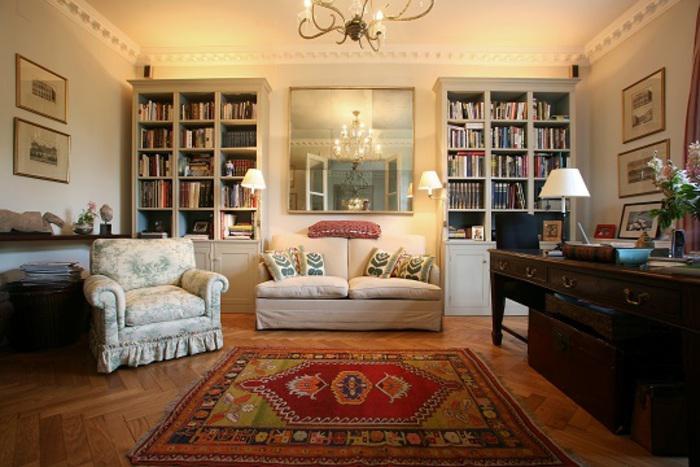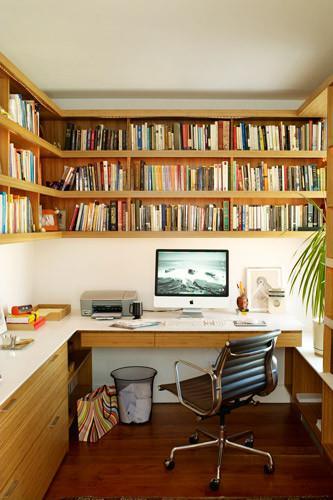The first image is the image on the left, the second image is the image on the right. Assess this claim about the two images: "A dark brown wood table is near a bookcase in one of the images.". Correct or not? Answer yes or no. Yes. The first image is the image on the left, the second image is the image on the right. For the images shown, is this caption "In one room, the back of a sofa is against the wall containing bookshelves and behind an oriental-type rug." true? Answer yes or no. Yes. 